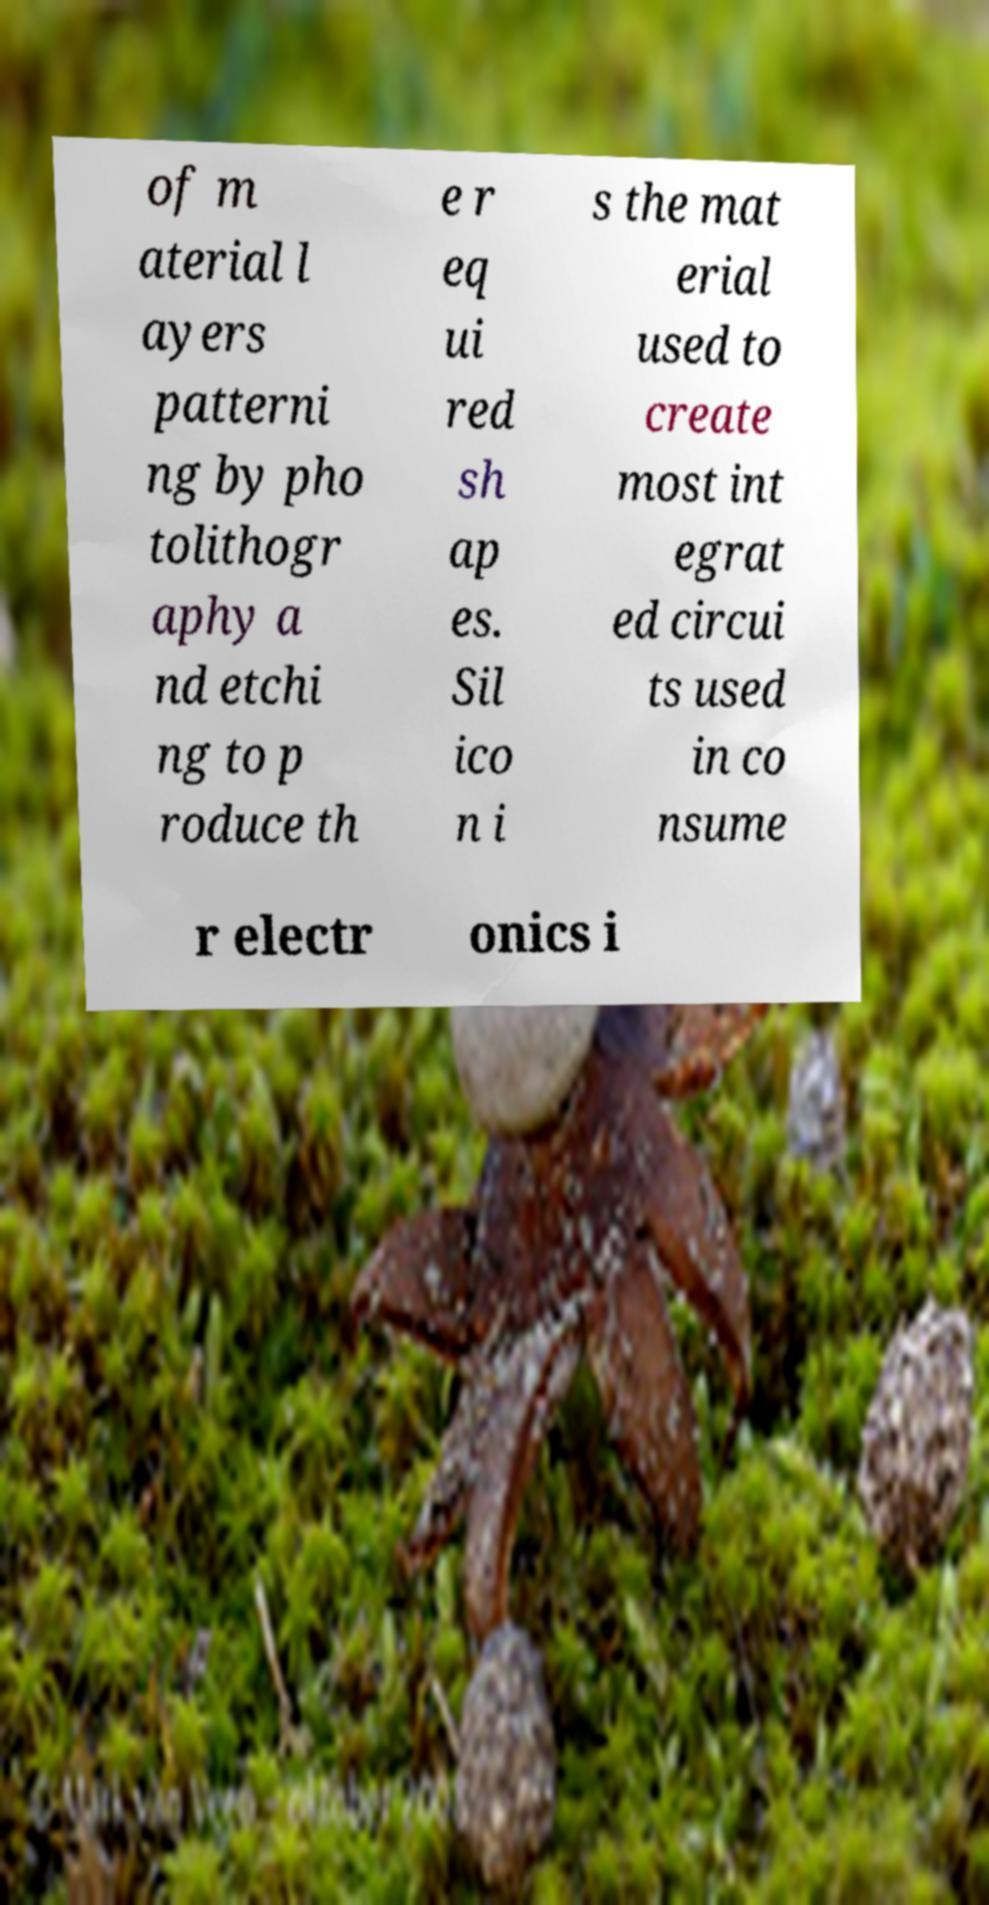Could you extract and type out the text from this image? of m aterial l ayers patterni ng by pho tolithogr aphy a nd etchi ng to p roduce th e r eq ui red sh ap es. Sil ico n i s the mat erial used to create most int egrat ed circui ts used in co nsume r electr onics i 